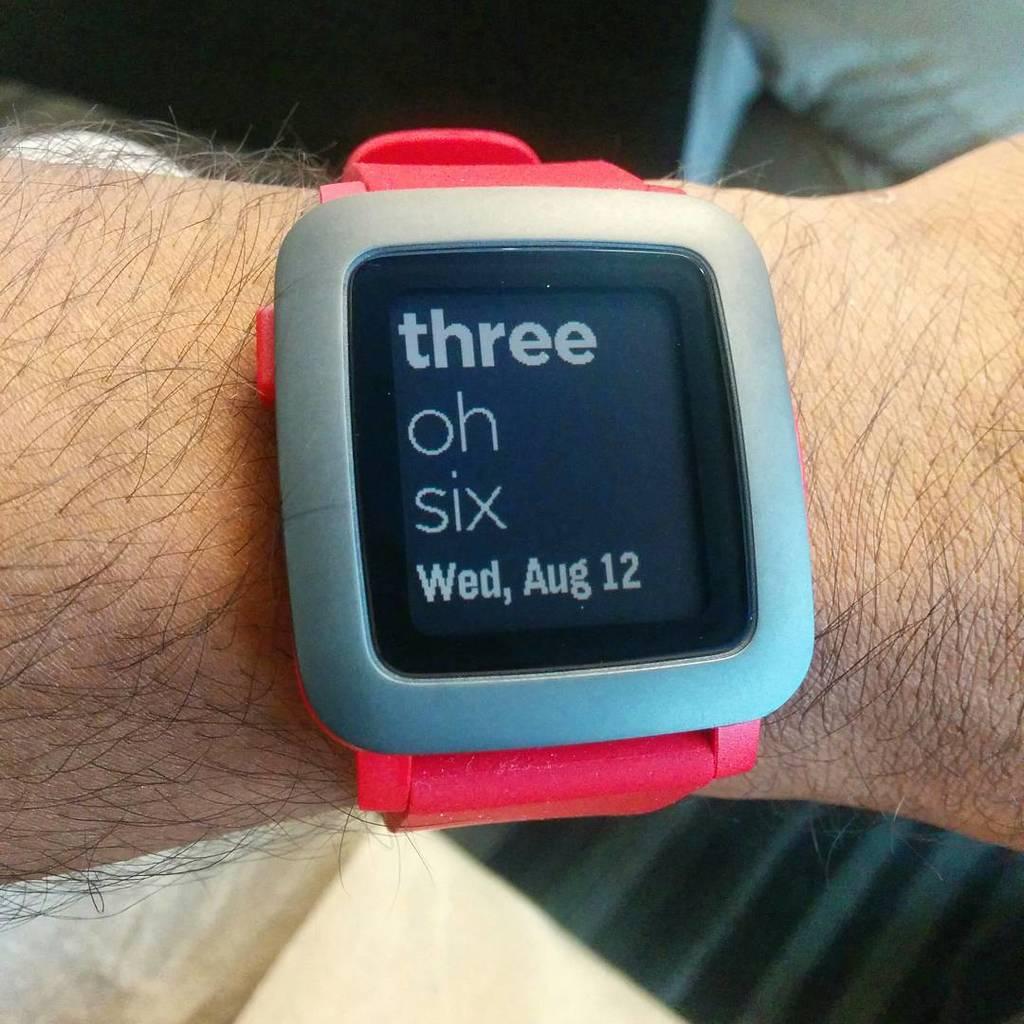What day is it?
Your answer should be very brief. Wednesday. It is watch?
Make the answer very short. Yes. 